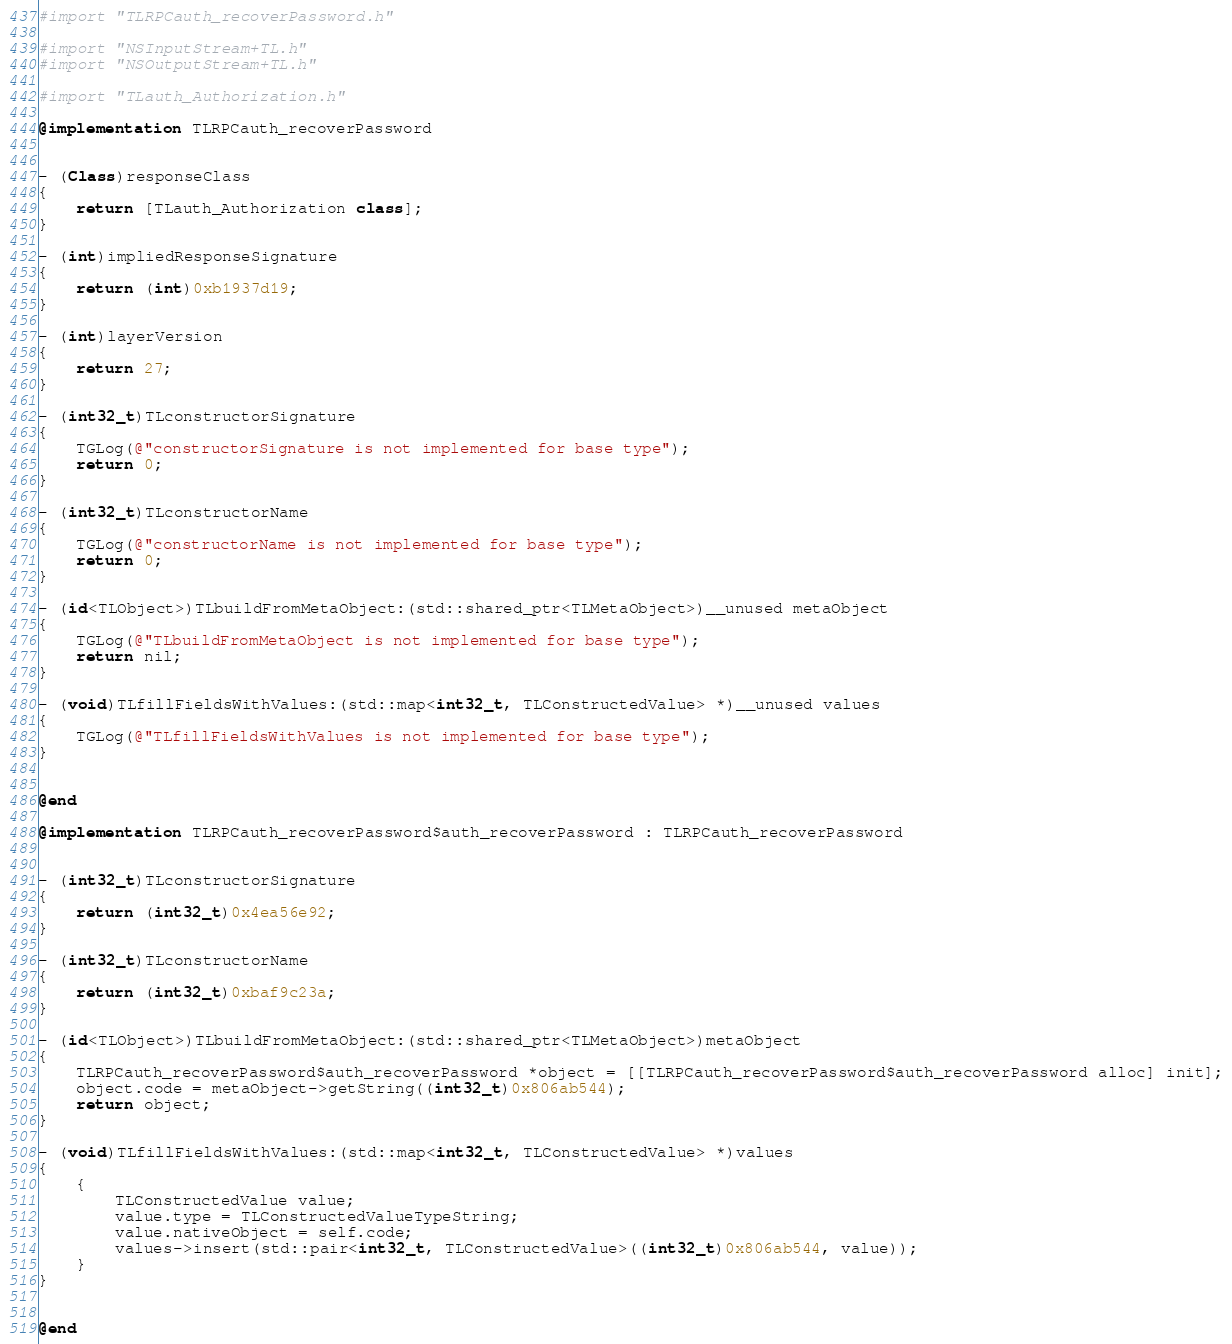<code> <loc_0><loc_0><loc_500><loc_500><_ObjectiveC_>#import "TLRPCauth_recoverPassword.h"

#import "NSInputStream+TL.h"
#import "NSOutputStream+TL.h"

#import "TLauth_Authorization.h"

@implementation TLRPCauth_recoverPassword


- (Class)responseClass
{
    return [TLauth_Authorization class];
}

- (int)impliedResponseSignature
{
    return (int)0xb1937d19;
}

- (int)layerVersion
{
    return 27;
}

- (int32_t)TLconstructorSignature
{
    TGLog(@"constructorSignature is not implemented for base type");
    return 0;
}

- (int32_t)TLconstructorName
{
    TGLog(@"constructorName is not implemented for base type");
    return 0;
}

- (id<TLObject>)TLbuildFromMetaObject:(std::shared_ptr<TLMetaObject>)__unused metaObject
{
    TGLog(@"TLbuildFromMetaObject is not implemented for base type");
    return nil;
}

- (void)TLfillFieldsWithValues:(std::map<int32_t, TLConstructedValue> *)__unused values
{
    TGLog(@"TLfillFieldsWithValues is not implemented for base type");
}


@end

@implementation TLRPCauth_recoverPassword$auth_recoverPassword : TLRPCauth_recoverPassword


- (int32_t)TLconstructorSignature
{
    return (int32_t)0x4ea56e92;
}

- (int32_t)TLconstructorName
{
    return (int32_t)0xbaf9c23a;
}

- (id<TLObject>)TLbuildFromMetaObject:(std::shared_ptr<TLMetaObject>)metaObject
{
    TLRPCauth_recoverPassword$auth_recoverPassword *object = [[TLRPCauth_recoverPassword$auth_recoverPassword alloc] init];
    object.code = metaObject->getString((int32_t)0x806ab544);
    return object;
}

- (void)TLfillFieldsWithValues:(std::map<int32_t, TLConstructedValue> *)values
{
    {
        TLConstructedValue value;
        value.type = TLConstructedValueTypeString;
        value.nativeObject = self.code;
        values->insert(std::pair<int32_t, TLConstructedValue>((int32_t)0x806ab544, value));
    }
}


@end

</code> 